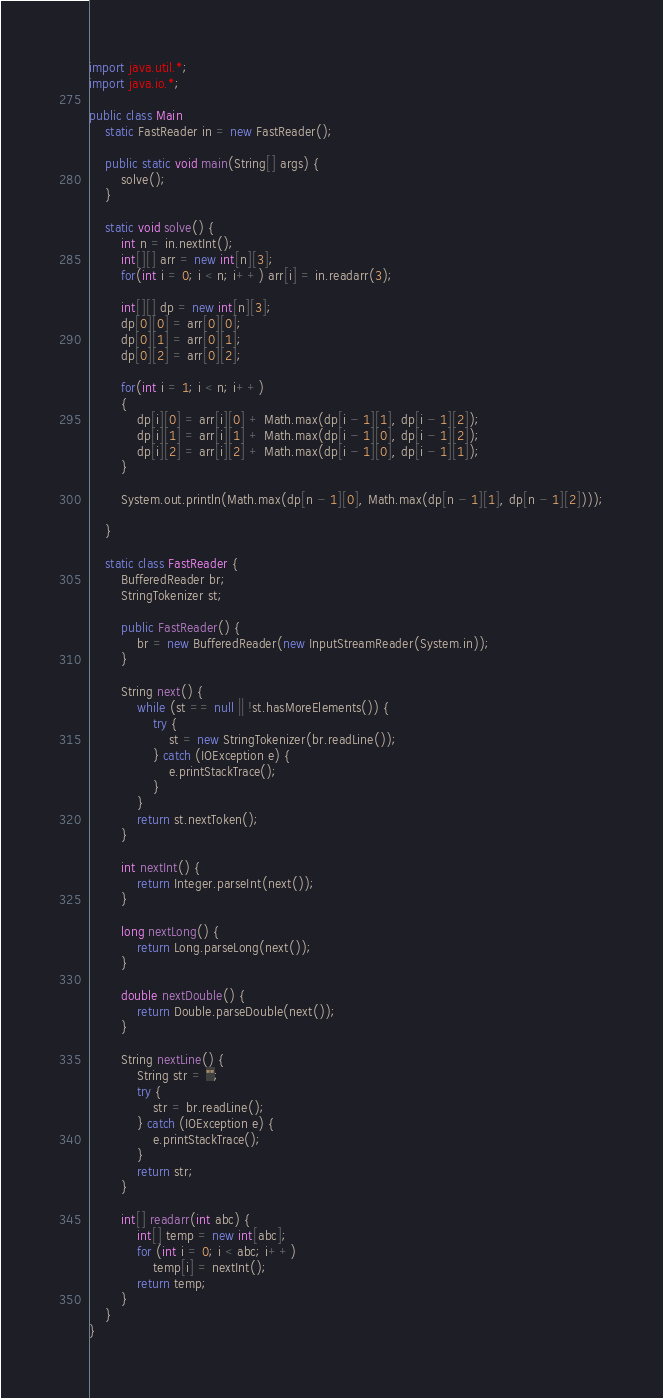Convert code to text. <code><loc_0><loc_0><loc_500><loc_500><_Java_>
import java.util.*;
import java.io.*;

public class Main
	static FastReader in = new FastReader();

	public static void main(String[] args) {
		solve();
	}

	static void solve() {
		int n = in.nextInt();
		int[][] arr = new int[n][3];
		for(int i = 0; i < n; i++) arr[i] = in.readarr(3);
		
		int[][] dp = new int[n][3];
		dp[0][0] = arr[0][0];
		dp[0][1] = arr[0][1];
		dp[0][2] = arr[0][2];
		
		for(int i = 1; i < n; i++)
		{
			dp[i][0] = arr[i][0] + Math.max(dp[i - 1][1], dp[i - 1][2]);
			dp[i][1] = arr[i][1] + Math.max(dp[i - 1][0], dp[i - 1][2]);
			dp[i][2] = arr[i][2] + Math.max(dp[i - 1][0], dp[i - 1][1]);
		}
				
		System.out.println(Math.max(dp[n - 1][0], Math.max(dp[n - 1][1], dp[n - 1][2])));
		
	}

	static class FastReader {
		BufferedReader br;
		StringTokenizer st;

		public FastReader() {
			br = new BufferedReader(new InputStreamReader(System.in));
		}

		String next() {
			while (st == null || !st.hasMoreElements()) {
				try {
					st = new StringTokenizer(br.readLine());
				} catch (IOException e) {
					e.printStackTrace();
				}
			}
			return st.nextToken();
		}

		int nextInt() {
			return Integer.parseInt(next());
		}

		long nextLong() {
			return Long.parseLong(next());
		}

		double nextDouble() {
			return Double.parseDouble(next());
		}

		String nextLine() {
			String str = "";
			try {
				str = br.readLine();
			} catch (IOException e) {
				e.printStackTrace();
			}
			return str;
		}

		int[] readarr(int abc) {
			int[] temp = new int[abc];
			for (int i = 0; i < abc; i++)
				temp[i] = nextInt();
			return temp;
		}
	}
}
</code> 